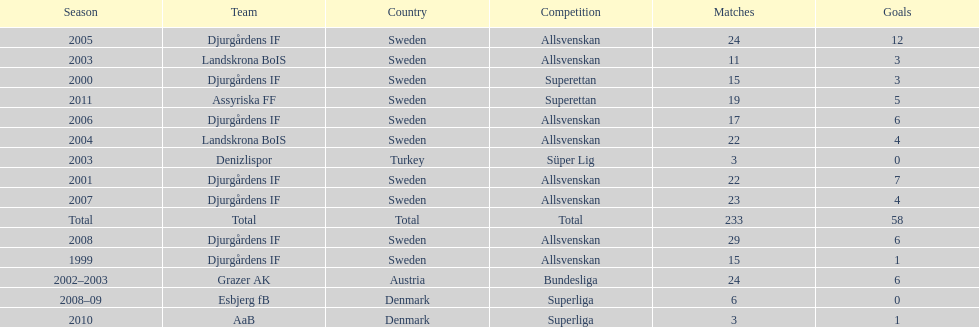What country is team djurgårdens if not from? Sweden. 